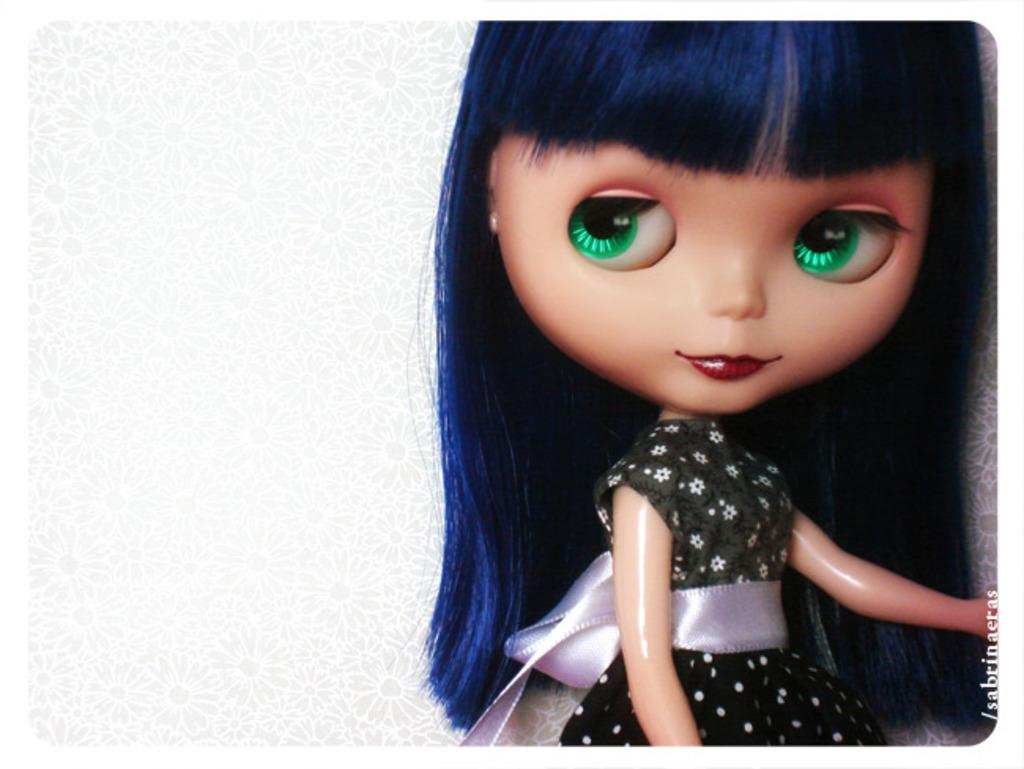What is located on the right side of the image? There is a doll on the right side of the image. What type of background is present in the image? There is a floral background in the image. Where is the text located in the image? The text is in the right corner of the image. What type of toothpaste is being used to clean the doll's toe in the image? There is no toothpaste or doll's toe present in the image. What is the doll cooking in the oven in the image? There is no oven or cooking activity depicted in the image. 